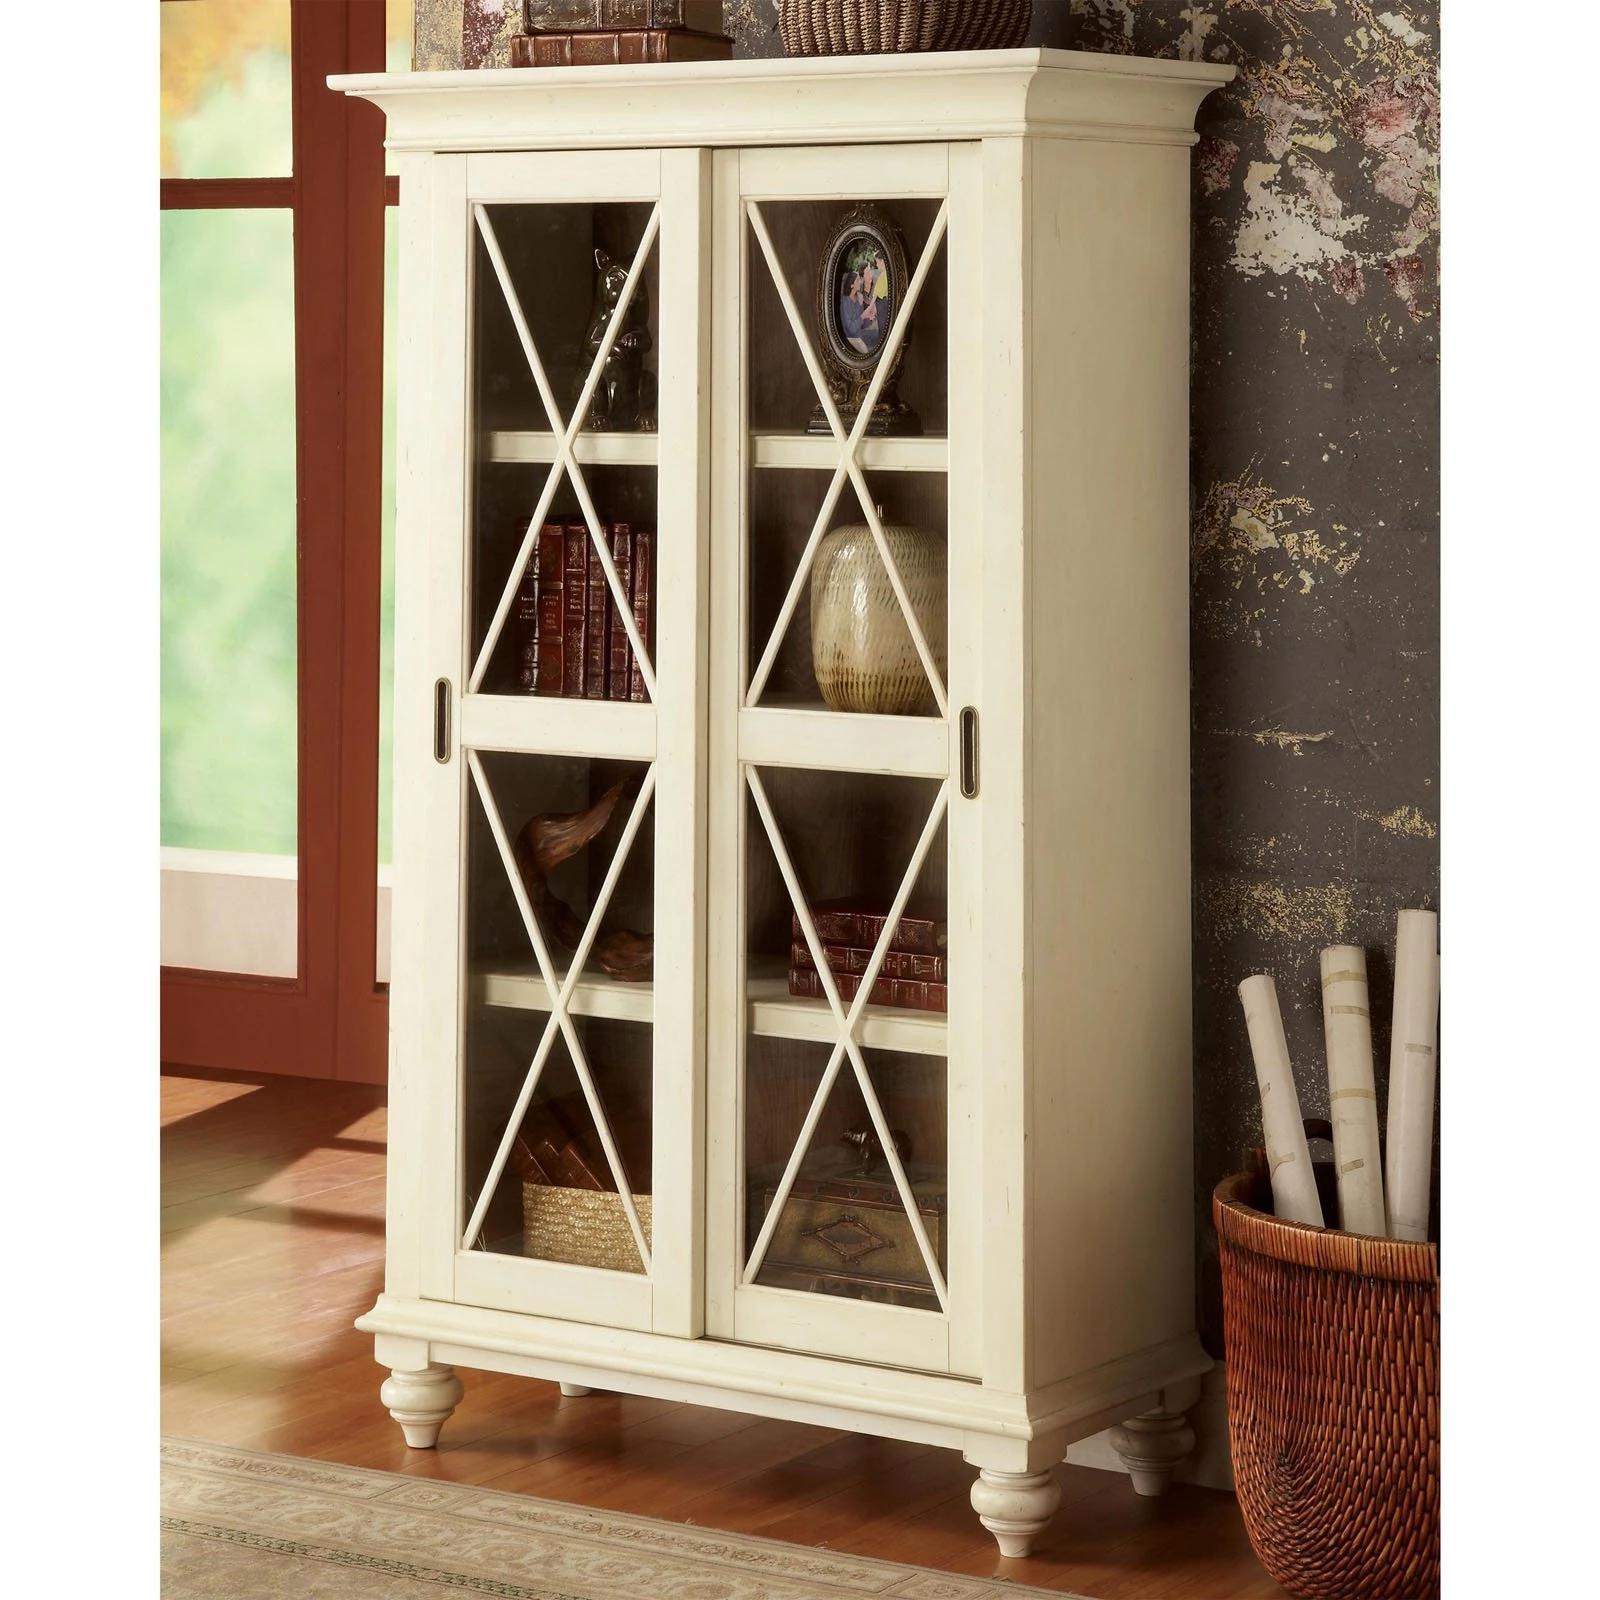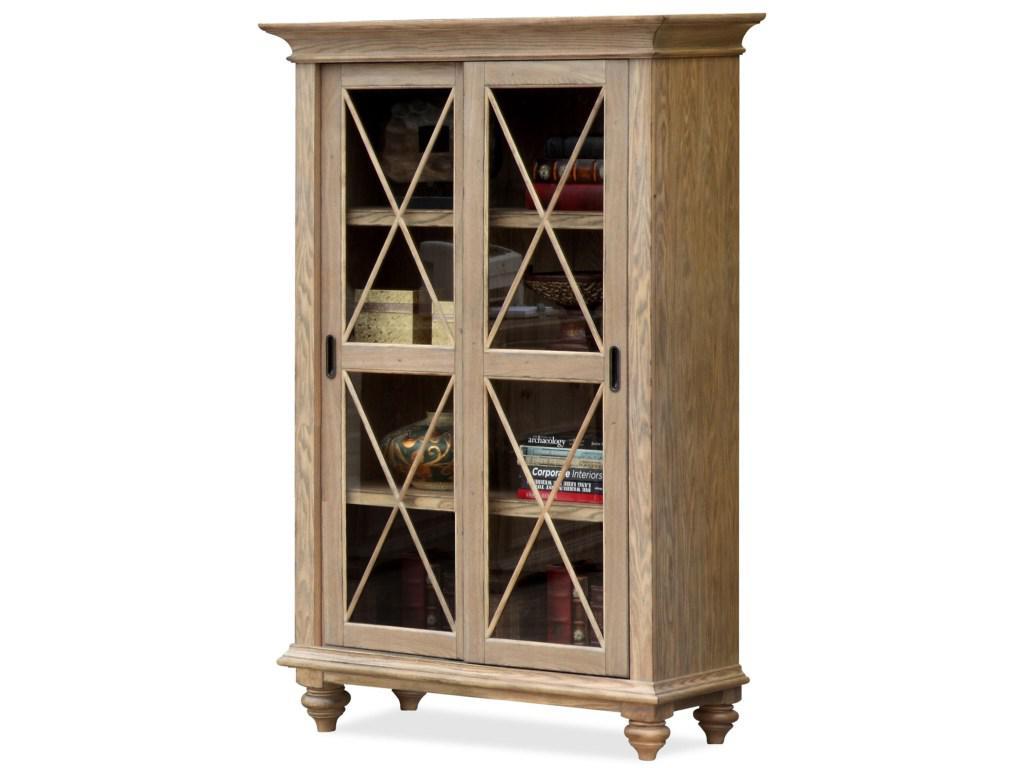The first image is the image on the left, the second image is the image on the right. Examine the images to the left and right. Is the description "The shelves in the image on the left have no doors." accurate? Answer yes or no. No. The first image is the image on the left, the second image is the image on the right. Assess this claim about the two images: "One image features a backless, sideless style of shelf storage in brown wood, and the other image features more traditional styling with glass-fronted enclosed white cabinets.". Correct or not? Answer yes or no. No. 